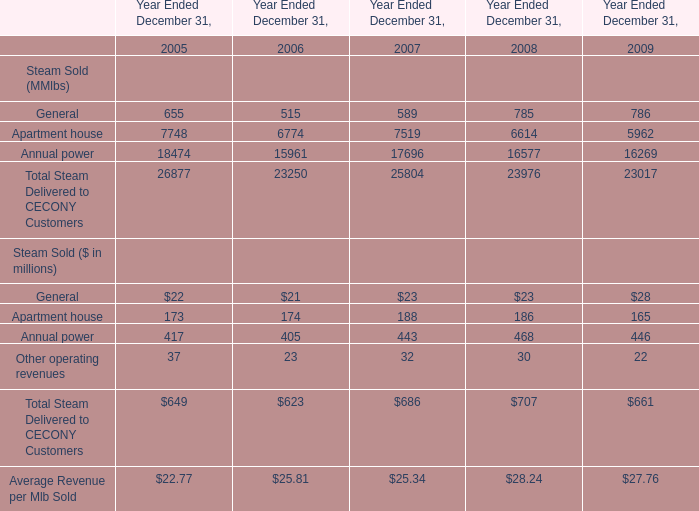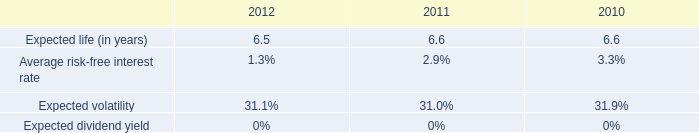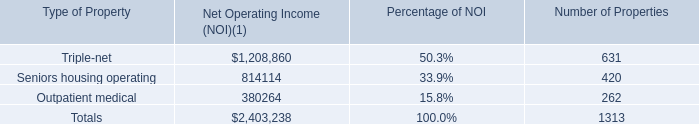What's the average of Annual power in 2005? (in MMlbs) 
Answer: 18474. 